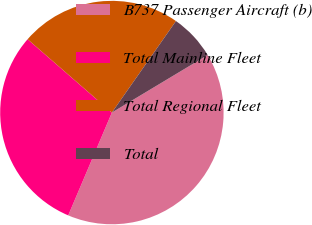Convert chart. <chart><loc_0><loc_0><loc_500><loc_500><pie_chart><fcel>B737 Passenger Aircraft (b)<fcel>Total Mainline Fleet<fcel>Total Regional Fleet<fcel>Total<nl><fcel>40.0%<fcel>30.0%<fcel>23.33%<fcel>6.67%<nl></chart> 